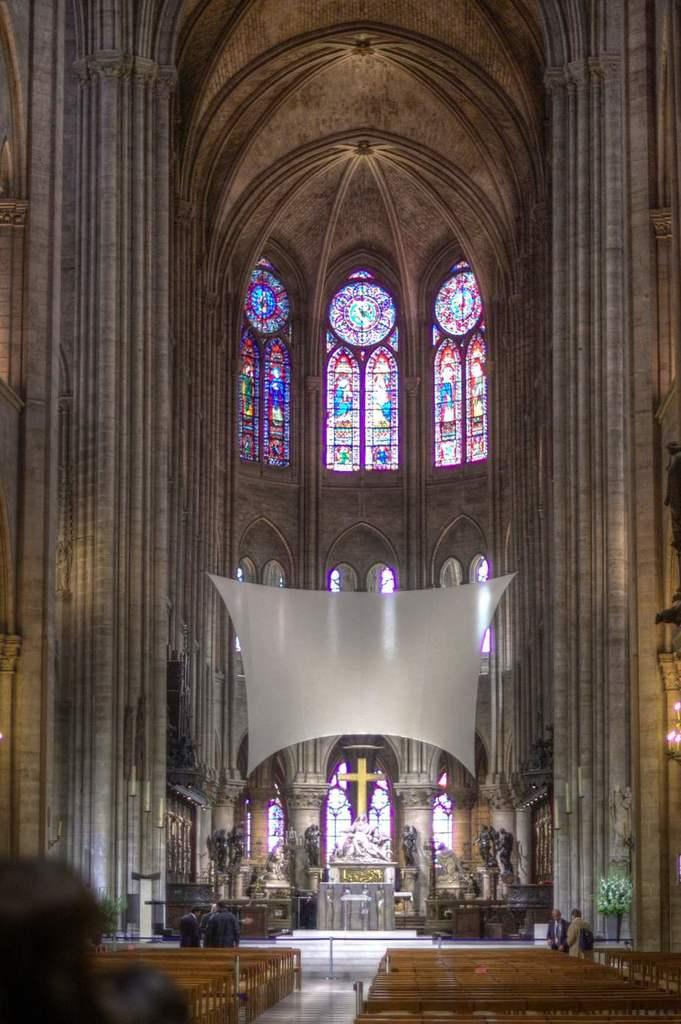What is the condition of the benches in the image? The benches in the image are empty. What are the people in the image doing? There are persons standing in the image. What type of objects can be seen in the image that are not people? There are statues and a plant in the image. What architectural features are present in the image? There are windows and a wall in the image. Can you tell me how many ears are visible on the persons standing in the image? There is no mention of ears in the image; we can only see that there are persons standing. What type of face can be seen on the tramp in the image? There is no tramp present in the image, so we cannot answer any questions about its face. 